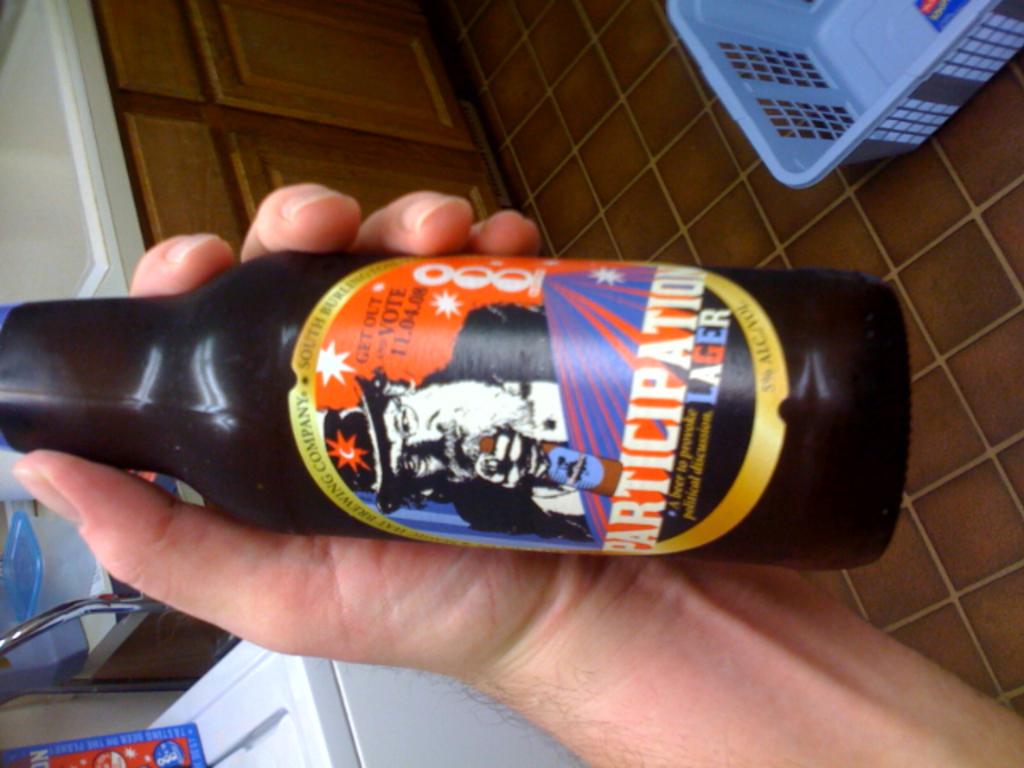What type of beer is it?
Ensure brevity in your answer.  Lager. The bottle says to get  out and do what?
Make the answer very short. Vote. 